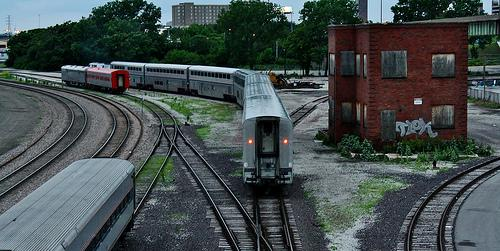Create a simple story that connects the graffiti on the red brick building to the train in the image. Once a bustling hub of activity, this train station was abandoned, leaving a red brick building and its trains behind. Over time, artists transformed the building's walls into a canvas for their graffiti, giving it a new life alongside the forgotten trains on the tracks. What type of structure besides the train is in the scene? There is a two-story red brick building in the scene. For the product advertisement task, imagine you're trying to sell a historical photography tour. Describe how this scene would be appealing to potential customers. Capture the beauty of forgotten spaces with our historical photography tour. In this scene, you'll find a red brick building adorned with graffiti, nestled between train tracks and wild nature. Let the contrasting colors of the red and gray trains inspire your creativity and create stunning, unique pictures. As an advertisement, how would you promote this location as an adventurous urban exploration site? Explore the abandoned trainyard, where history meets art. Discover the red brick building, marvel at the graffiti, and see how nature reclaims the old train cars. Unveil the story behind this urban gem. Identify the subject that would be grounded in the referential expression "the large building with boarded windows." The red brick building between the tracks. What is the surrounding environment like in the image? There are green trees in the background, a tall building, train tracks curving to the left, and black gravel between the train and the building. Describe the notable features of both the train tracks and the train cars. The train tracks are curving to the left and are connected, while the train cars include a red passenger car, a silver passenger train, and a short silver train. Name at least two things about the red brick building and two things about the train. The red brick building has boarded-up windows and graffiti, while the train is gray and has red lights. Identify the primary building in the image and its main features. A red brick building is between the tracks with boarded-up windows, and there is graffiti on its wall. What type of train is present in the image and what are its two main colors? There is a double-decker train on the tracks, and its two main colors are gray and red. 